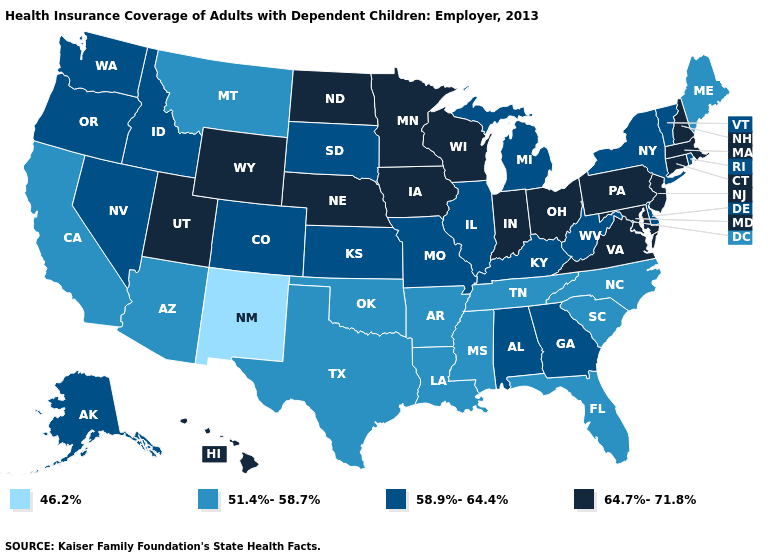Does New Mexico have the lowest value in the USA?
Give a very brief answer. Yes. Name the states that have a value in the range 46.2%?
Be succinct. New Mexico. Among the states that border Wyoming , which have the highest value?
Short answer required. Nebraska, Utah. Name the states that have a value in the range 64.7%-71.8%?
Quick response, please. Connecticut, Hawaii, Indiana, Iowa, Maryland, Massachusetts, Minnesota, Nebraska, New Hampshire, New Jersey, North Dakota, Ohio, Pennsylvania, Utah, Virginia, Wisconsin, Wyoming. What is the value of Indiana?
Keep it brief. 64.7%-71.8%. What is the value of North Dakota?
Quick response, please. 64.7%-71.8%. Name the states that have a value in the range 46.2%?
Concise answer only. New Mexico. Does Ohio have the same value as Arkansas?
Quick response, please. No. What is the value of Connecticut?
Concise answer only. 64.7%-71.8%. Does North Dakota have the highest value in the USA?
Concise answer only. Yes. How many symbols are there in the legend?
Give a very brief answer. 4. Name the states that have a value in the range 58.9%-64.4%?
Quick response, please. Alabama, Alaska, Colorado, Delaware, Georgia, Idaho, Illinois, Kansas, Kentucky, Michigan, Missouri, Nevada, New York, Oregon, Rhode Island, South Dakota, Vermont, Washington, West Virginia. Does the first symbol in the legend represent the smallest category?
Give a very brief answer. Yes. Name the states that have a value in the range 46.2%?
Keep it brief. New Mexico. Name the states that have a value in the range 64.7%-71.8%?
Write a very short answer. Connecticut, Hawaii, Indiana, Iowa, Maryland, Massachusetts, Minnesota, Nebraska, New Hampshire, New Jersey, North Dakota, Ohio, Pennsylvania, Utah, Virginia, Wisconsin, Wyoming. 